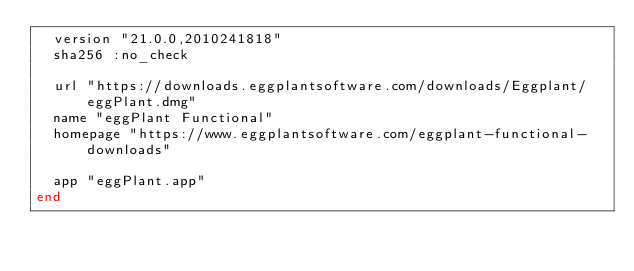<code> <loc_0><loc_0><loc_500><loc_500><_Ruby_>  version "21.0.0,2010241818"
  sha256 :no_check

  url "https://downloads.eggplantsoftware.com/downloads/Eggplant/eggPlant.dmg"
  name "eggPlant Functional"
  homepage "https://www.eggplantsoftware.com/eggplant-functional-downloads"

  app "eggPlant.app"
end
</code> 